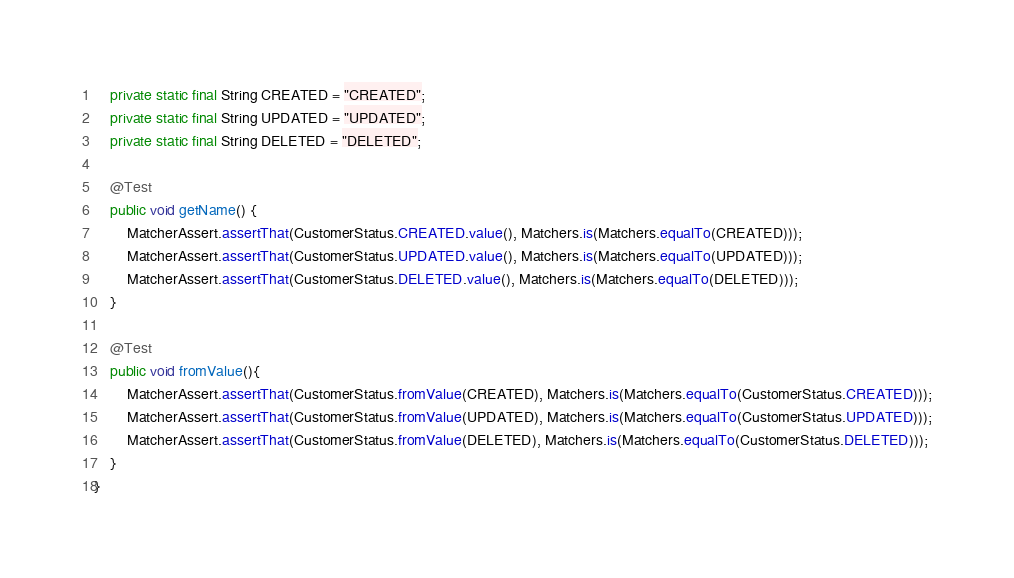<code> <loc_0><loc_0><loc_500><loc_500><_Java_>
    private static final String CREATED = "CREATED";
    private static final String UPDATED = "UPDATED";
    private static final String DELETED = "DELETED";

    @Test
    public void getName() {
        MatcherAssert.assertThat(CustomerStatus.CREATED.value(), Matchers.is(Matchers.equalTo(CREATED)));
        MatcherAssert.assertThat(CustomerStatus.UPDATED.value(), Matchers.is(Matchers.equalTo(UPDATED)));
        MatcherAssert.assertThat(CustomerStatus.DELETED.value(), Matchers.is(Matchers.equalTo(DELETED)));
    }

    @Test
    public void fromValue(){
        MatcherAssert.assertThat(CustomerStatus.fromValue(CREATED), Matchers.is(Matchers.equalTo(CustomerStatus.CREATED)));
        MatcherAssert.assertThat(CustomerStatus.fromValue(UPDATED), Matchers.is(Matchers.equalTo(CustomerStatus.UPDATED)));
        MatcherAssert.assertThat(CustomerStatus.fromValue(DELETED), Matchers.is(Matchers.equalTo(CustomerStatus.DELETED)));
    }
}
</code> 